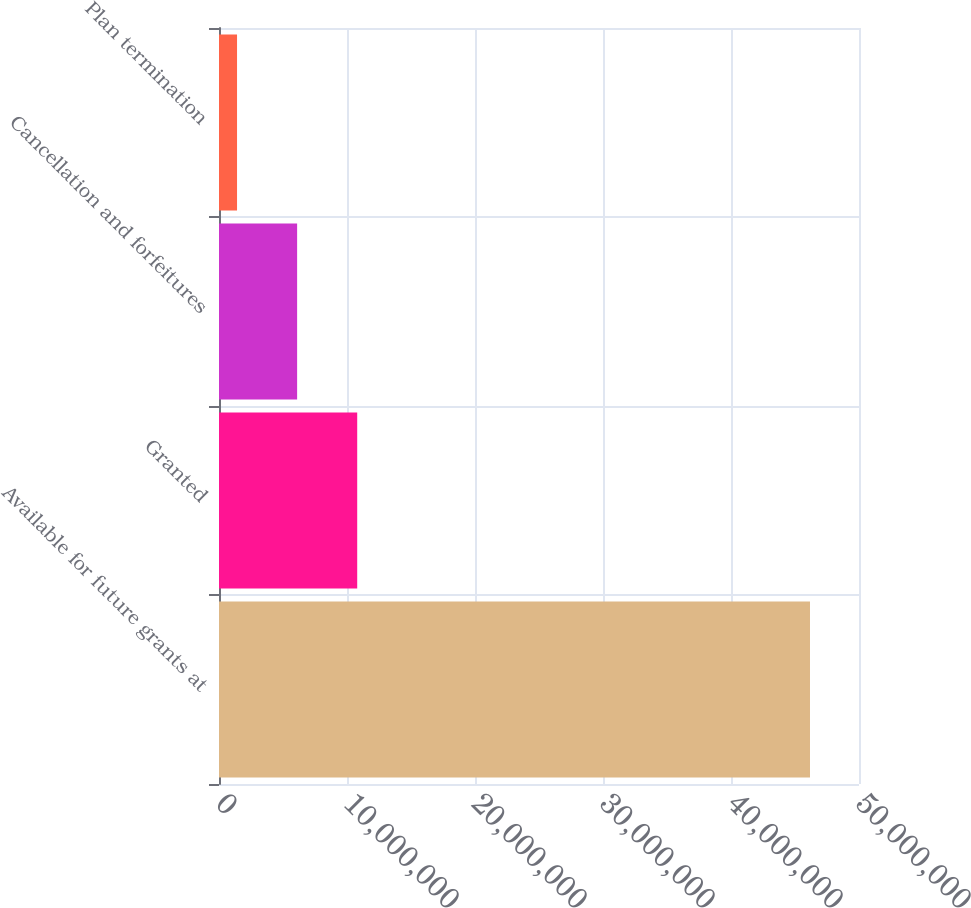<chart> <loc_0><loc_0><loc_500><loc_500><bar_chart><fcel>Available for future grants at<fcel>Granted<fcel>Cancellation and forfeitures<fcel>Plan termination<nl><fcel>4.61711e+07<fcel>1.07977e+07<fcel>6.10338e+06<fcel>1.40906e+06<nl></chart> 